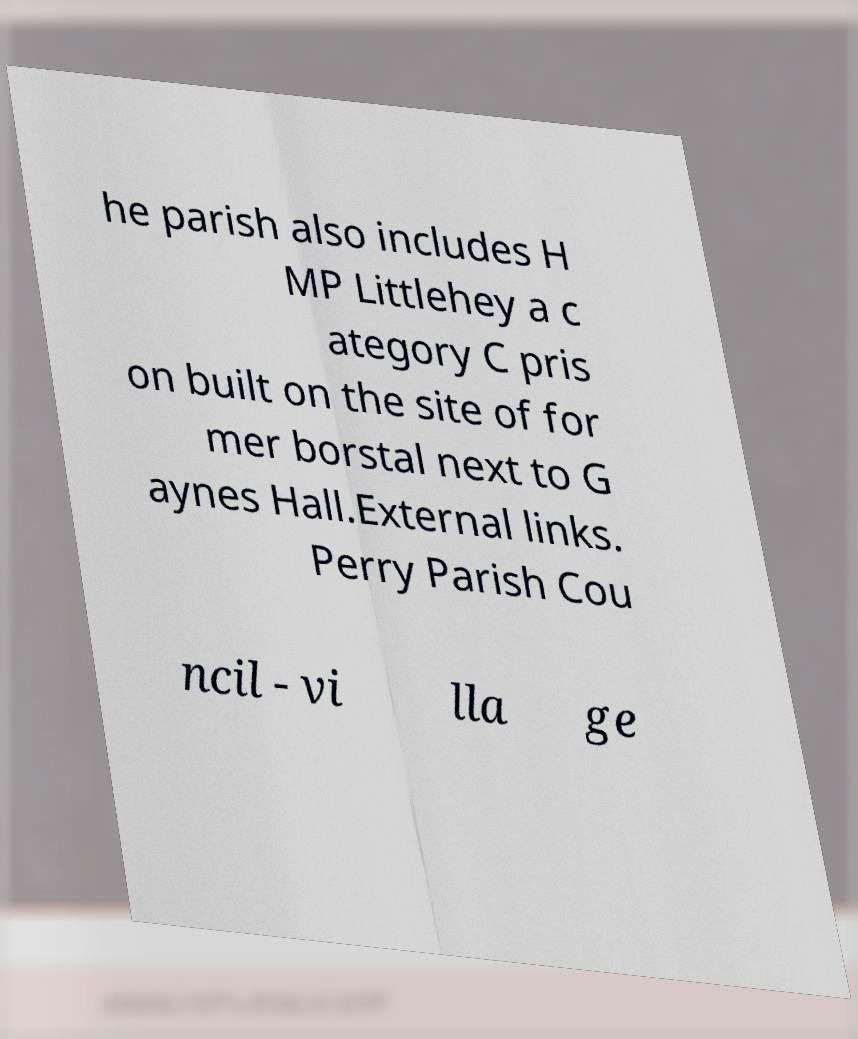Can you accurately transcribe the text from the provided image for me? he parish also includes H MP Littlehey a c ategory C pris on built on the site of for mer borstal next to G aynes Hall.External links. Perry Parish Cou ncil - vi lla ge 